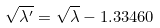Convert formula to latex. <formula><loc_0><loc_0><loc_500><loc_500>\sqrt { \lambda ^ { \prime } } = \sqrt { \lambda } - 1 . 3 3 4 6 0</formula> 